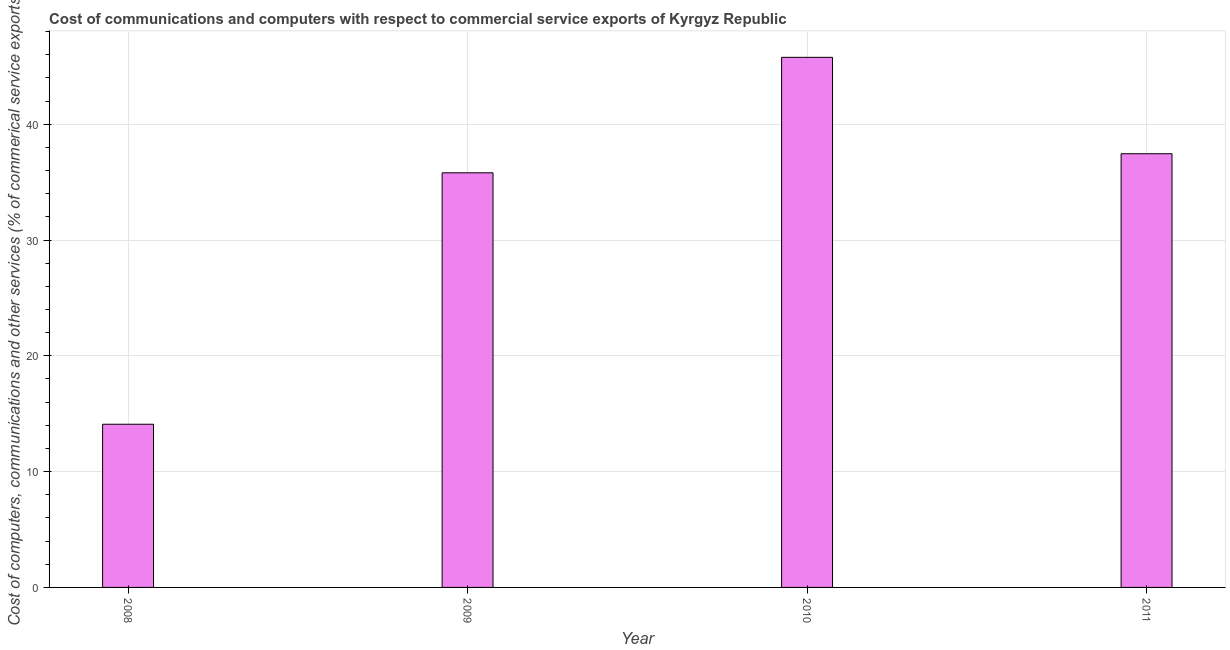What is the title of the graph?
Keep it short and to the point. Cost of communications and computers with respect to commercial service exports of Kyrgyz Republic. What is the label or title of the X-axis?
Your response must be concise. Year. What is the label or title of the Y-axis?
Offer a very short reply. Cost of computers, communications and other services (% of commerical service exports). What is the cost of communications in 2010?
Give a very brief answer. 45.78. Across all years, what is the maximum  computer and other services?
Offer a terse response. 45.78. Across all years, what is the minimum cost of communications?
Give a very brief answer. 14.09. What is the sum of the cost of communications?
Offer a very short reply. 133.13. What is the difference between the cost of communications in 2008 and 2011?
Keep it short and to the point. -23.36. What is the average cost of communications per year?
Provide a short and direct response. 33.28. What is the median cost of communications?
Provide a succinct answer. 36.63. In how many years, is the  computer and other services greater than 18 %?
Ensure brevity in your answer.  3. Do a majority of the years between 2011 and 2010 (inclusive) have  computer and other services greater than 30 %?
Ensure brevity in your answer.  No. What is the ratio of the  computer and other services in 2009 to that in 2011?
Give a very brief answer. 0.96. What is the difference between the highest and the second highest cost of communications?
Offer a terse response. 8.32. What is the difference between the highest and the lowest cost of communications?
Offer a very short reply. 31.69. In how many years, is the cost of communications greater than the average cost of communications taken over all years?
Your answer should be compact. 3. Are all the bars in the graph horizontal?
Give a very brief answer. No. How many years are there in the graph?
Provide a short and direct response. 4. What is the difference between two consecutive major ticks on the Y-axis?
Make the answer very short. 10. What is the Cost of computers, communications and other services (% of commerical service exports) in 2008?
Keep it short and to the point. 14.09. What is the Cost of computers, communications and other services (% of commerical service exports) in 2009?
Your answer should be very brief. 35.81. What is the Cost of computers, communications and other services (% of commerical service exports) in 2010?
Offer a terse response. 45.78. What is the Cost of computers, communications and other services (% of commerical service exports) of 2011?
Offer a very short reply. 37.45. What is the difference between the Cost of computers, communications and other services (% of commerical service exports) in 2008 and 2009?
Provide a short and direct response. -21.71. What is the difference between the Cost of computers, communications and other services (% of commerical service exports) in 2008 and 2010?
Your answer should be compact. -31.69. What is the difference between the Cost of computers, communications and other services (% of commerical service exports) in 2008 and 2011?
Ensure brevity in your answer.  -23.36. What is the difference between the Cost of computers, communications and other services (% of commerical service exports) in 2009 and 2010?
Give a very brief answer. -9.97. What is the difference between the Cost of computers, communications and other services (% of commerical service exports) in 2009 and 2011?
Provide a succinct answer. -1.65. What is the difference between the Cost of computers, communications and other services (% of commerical service exports) in 2010 and 2011?
Your response must be concise. 8.32. What is the ratio of the Cost of computers, communications and other services (% of commerical service exports) in 2008 to that in 2009?
Keep it short and to the point. 0.39. What is the ratio of the Cost of computers, communications and other services (% of commerical service exports) in 2008 to that in 2010?
Give a very brief answer. 0.31. What is the ratio of the Cost of computers, communications and other services (% of commerical service exports) in 2008 to that in 2011?
Offer a terse response. 0.38. What is the ratio of the Cost of computers, communications and other services (% of commerical service exports) in 2009 to that in 2010?
Ensure brevity in your answer.  0.78. What is the ratio of the Cost of computers, communications and other services (% of commerical service exports) in 2009 to that in 2011?
Make the answer very short. 0.96. What is the ratio of the Cost of computers, communications and other services (% of commerical service exports) in 2010 to that in 2011?
Your answer should be very brief. 1.22. 